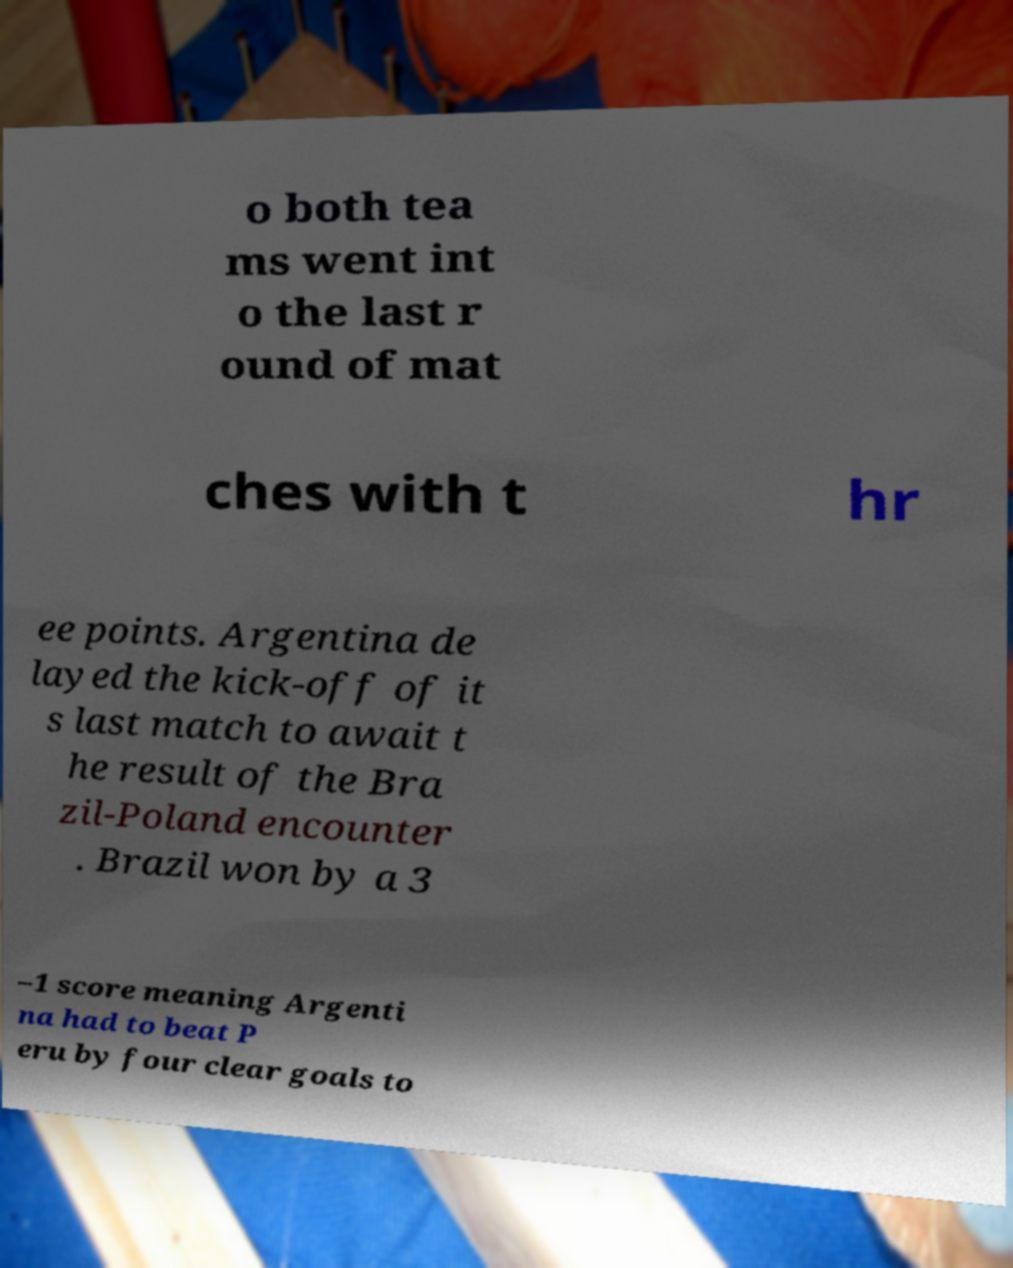There's text embedded in this image that I need extracted. Can you transcribe it verbatim? o both tea ms went int o the last r ound of mat ches with t hr ee points. Argentina de layed the kick-off of it s last match to await t he result of the Bra zil-Poland encounter . Brazil won by a 3 –1 score meaning Argenti na had to beat P eru by four clear goals to 